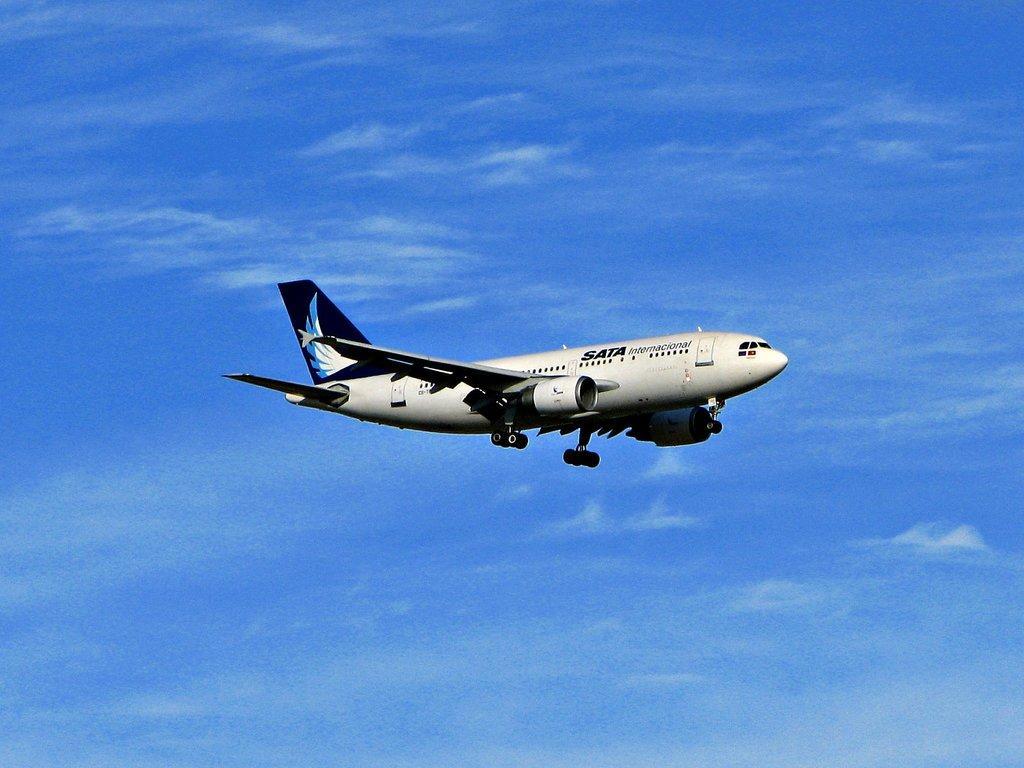Could you give a brief overview of what you see in this image? In this picture, we see an airplane in white color is flying in the sky. In the background, we see the sky, which is blue in color. 